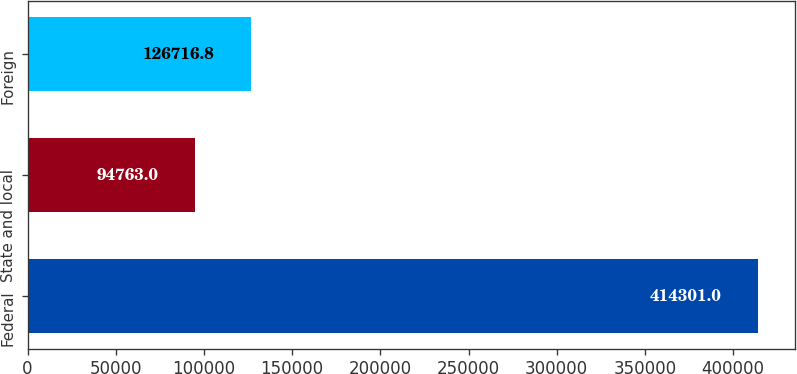Convert chart to OTSL. <chart><loc_0><loc_0><loc_500><loc_500><bar_chart><fcel>Federal<fcel>State and local<fcel>Foreign<nl><fcel>414301<fcel>94763<fcel>126717<nl></chart> 